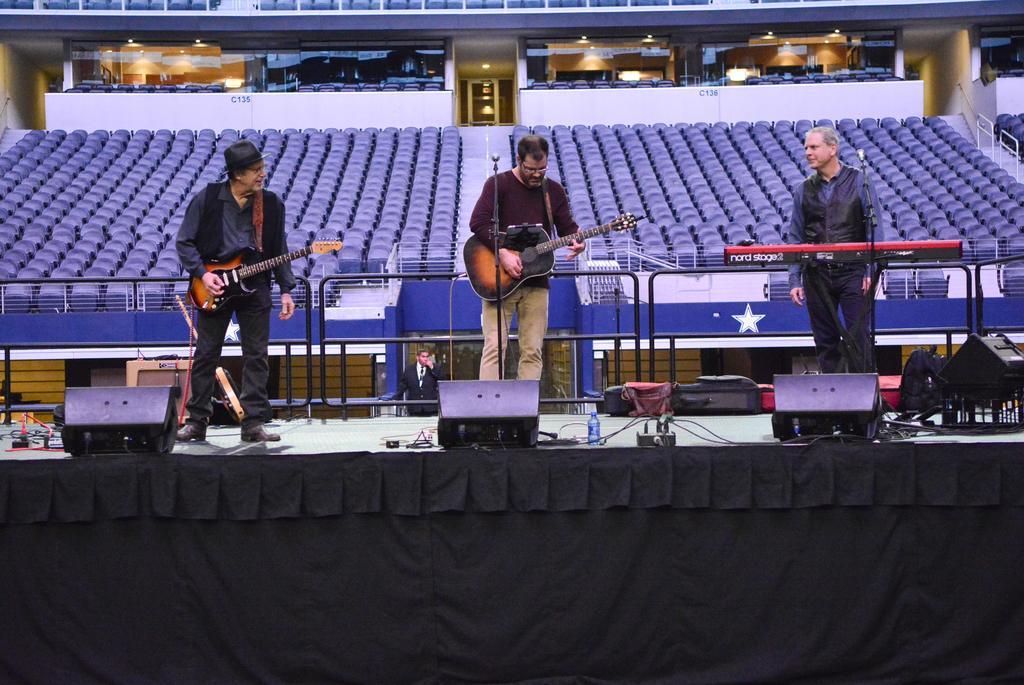Please provide a concise description of this image. In this picture we can see three men on stage where two are holding guitars in their hands and playing it and one is standing in front of piano and in front of them we have mics and in background we can see some person standing, chairs, way, light, glass, fence, bottle. 